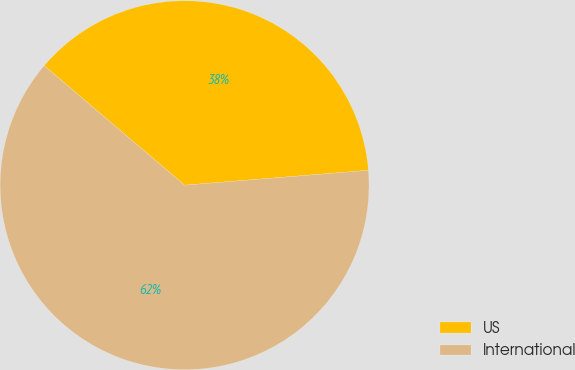Convert chart. <chart><loc_0><loc_0><loc_500><loc_500><pie_chart><fcel>US<fcel>International<nl><fcel>37.5%<fcel>62.5%<nl></chart> 